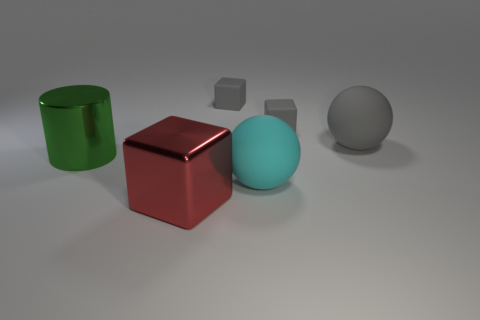Can you describe the colors and shapes of objects in the image? Certainly! In the image, we have five objects. Starting from the left, there's a reflective green cylinder, next to it is a matte red cube, followed by a smaller gray cube, then a cyan sphere with a glossy finish, and finally, on the far right, a grayish sphere with a less reflective surface than the cyan one. 